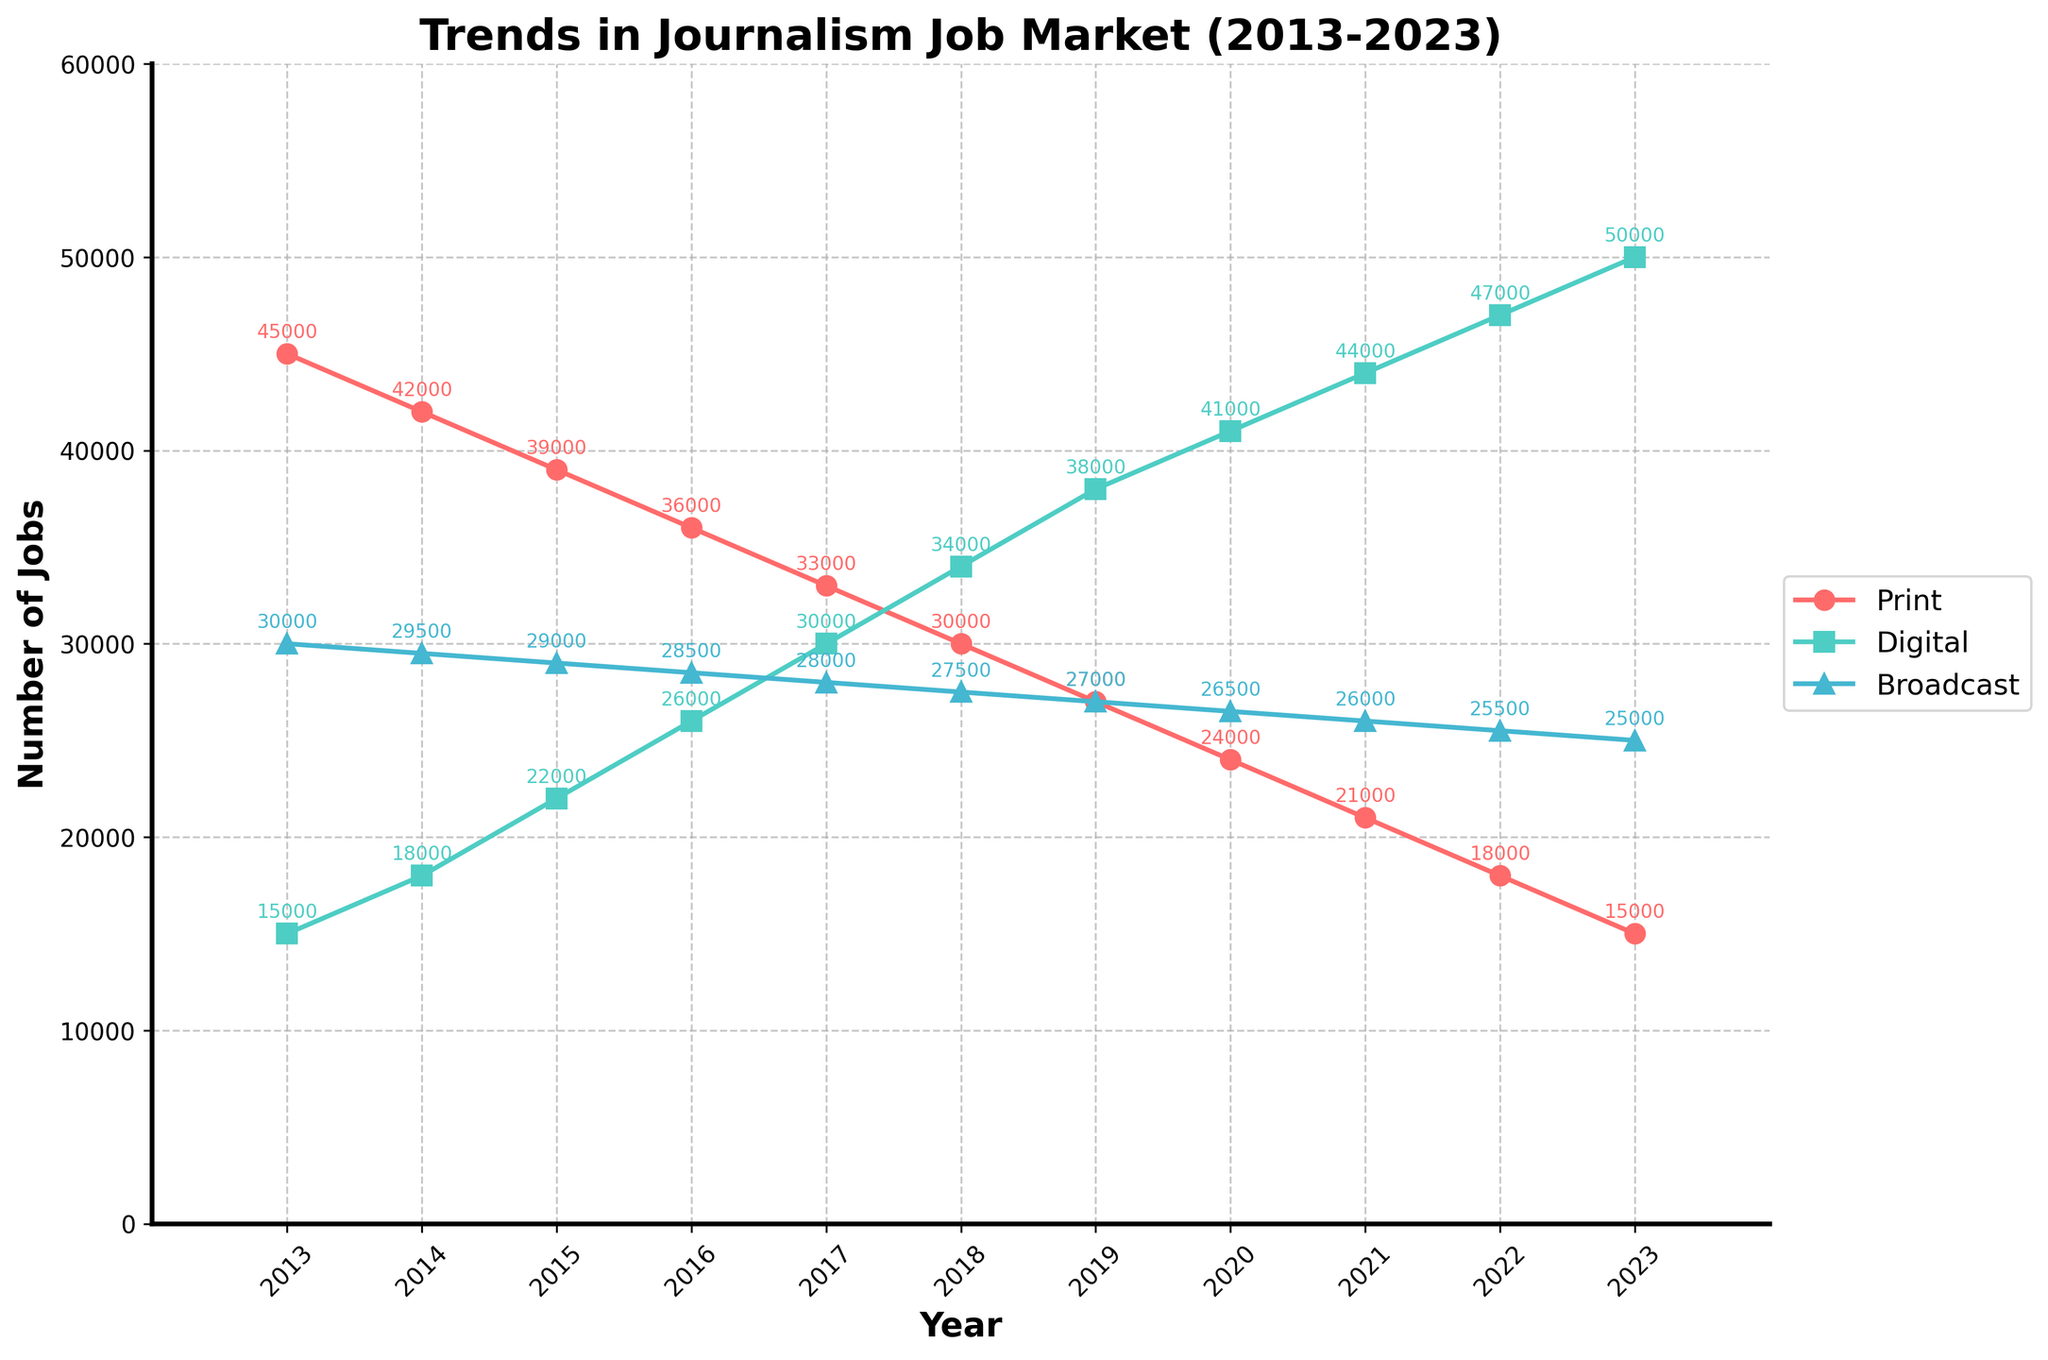What is the total number of digital journalism jobs in 2017 and 2023 combined? First, identify the digital journalism jobs in 2017 and 2023 from the plot. They are 30,000 and 50,000 respectively. Add these values together: 30,000 + 50,000 = 80,000.
Answer: 80,000 Which year saw the highest number of print journalism jobs? Observe the plot to find the peak point for print journalism jobs, which is represented by the red line. The highest value occurs in 2013.
Answer: 2013 How many fewer broadcast journalism jobs were there in 2023 compared to 2013? Locate the broadcast journalism jobs in 2023 and 2013 from the plot. They are 25,000 and 30,000 respectively. Subtract the 2023 value from the 2013 value: 30,000 - 25,000 = 5,000.
Answer: 5,000 What is the trend of digital journalism jobs from 2013 to 2023? Analyze the graph to observe the trend of digital journalism jobs, which is depicted by the green line. The line shows a consistent increase yearly from 2013 to 2023.
Answer: Increasing In which year do digital journalism jobs surpass print journalism jobs? Compare both the red and green lines on the graph to determine the crossover point. Digital journalism jobs surpass print journalism jobs in 2016.
Answer: 2016 How does the number of broadcast journalism jobs in 2018 compare to the number in 2022? Compare the values from the plot for broadcast journalism jobs in 2018 and 2022, which are 27,500 and 25,500 respectively. Therefore, there were more jobs in 2018 than in 2022.
Answer: More in 2018 By how much did print journalism jobs decrease from 2013 to 2019? Find the values for print journalism jobs in 2013 and 2019 from the graph, which are 45,000 and 27,000 respectively. Subtract the 2019 value from the 2013 value: 45,000 - 27,000 = 18,000.
Answer: 18,000 What is the average number of digital journalism jobs from 2013 to 2023? Sum up all the digital journalism job values from the plot (15,000 + 18,000 + 22,000 + 26,000 + 30,000 + 34,000 + 38,000 + 41,000 + 44,000 + 47,000 + 50,000) = 365,000. Divide by the number of years (365,000 / 11) = 33,182 (approx).
Answer: 33,182 How did the number of print journalism jobs change between 2013 and 2023? Compare the start and end points of the red line on the graph. The number of print journalism jobs decreased from 45,000 in 2013 to 15,000 in 2023.
Answer: Decreased What can you infer about the overall trend for broadcast journalism jobs from 2013 to 2023? Examine the blue line on the graph, which shows relatively small changes in broadcast journalism jobs over the decade, indicating a fairly stable trend with a slight decrease.
Answer: Fairly stable with a slight decrease 